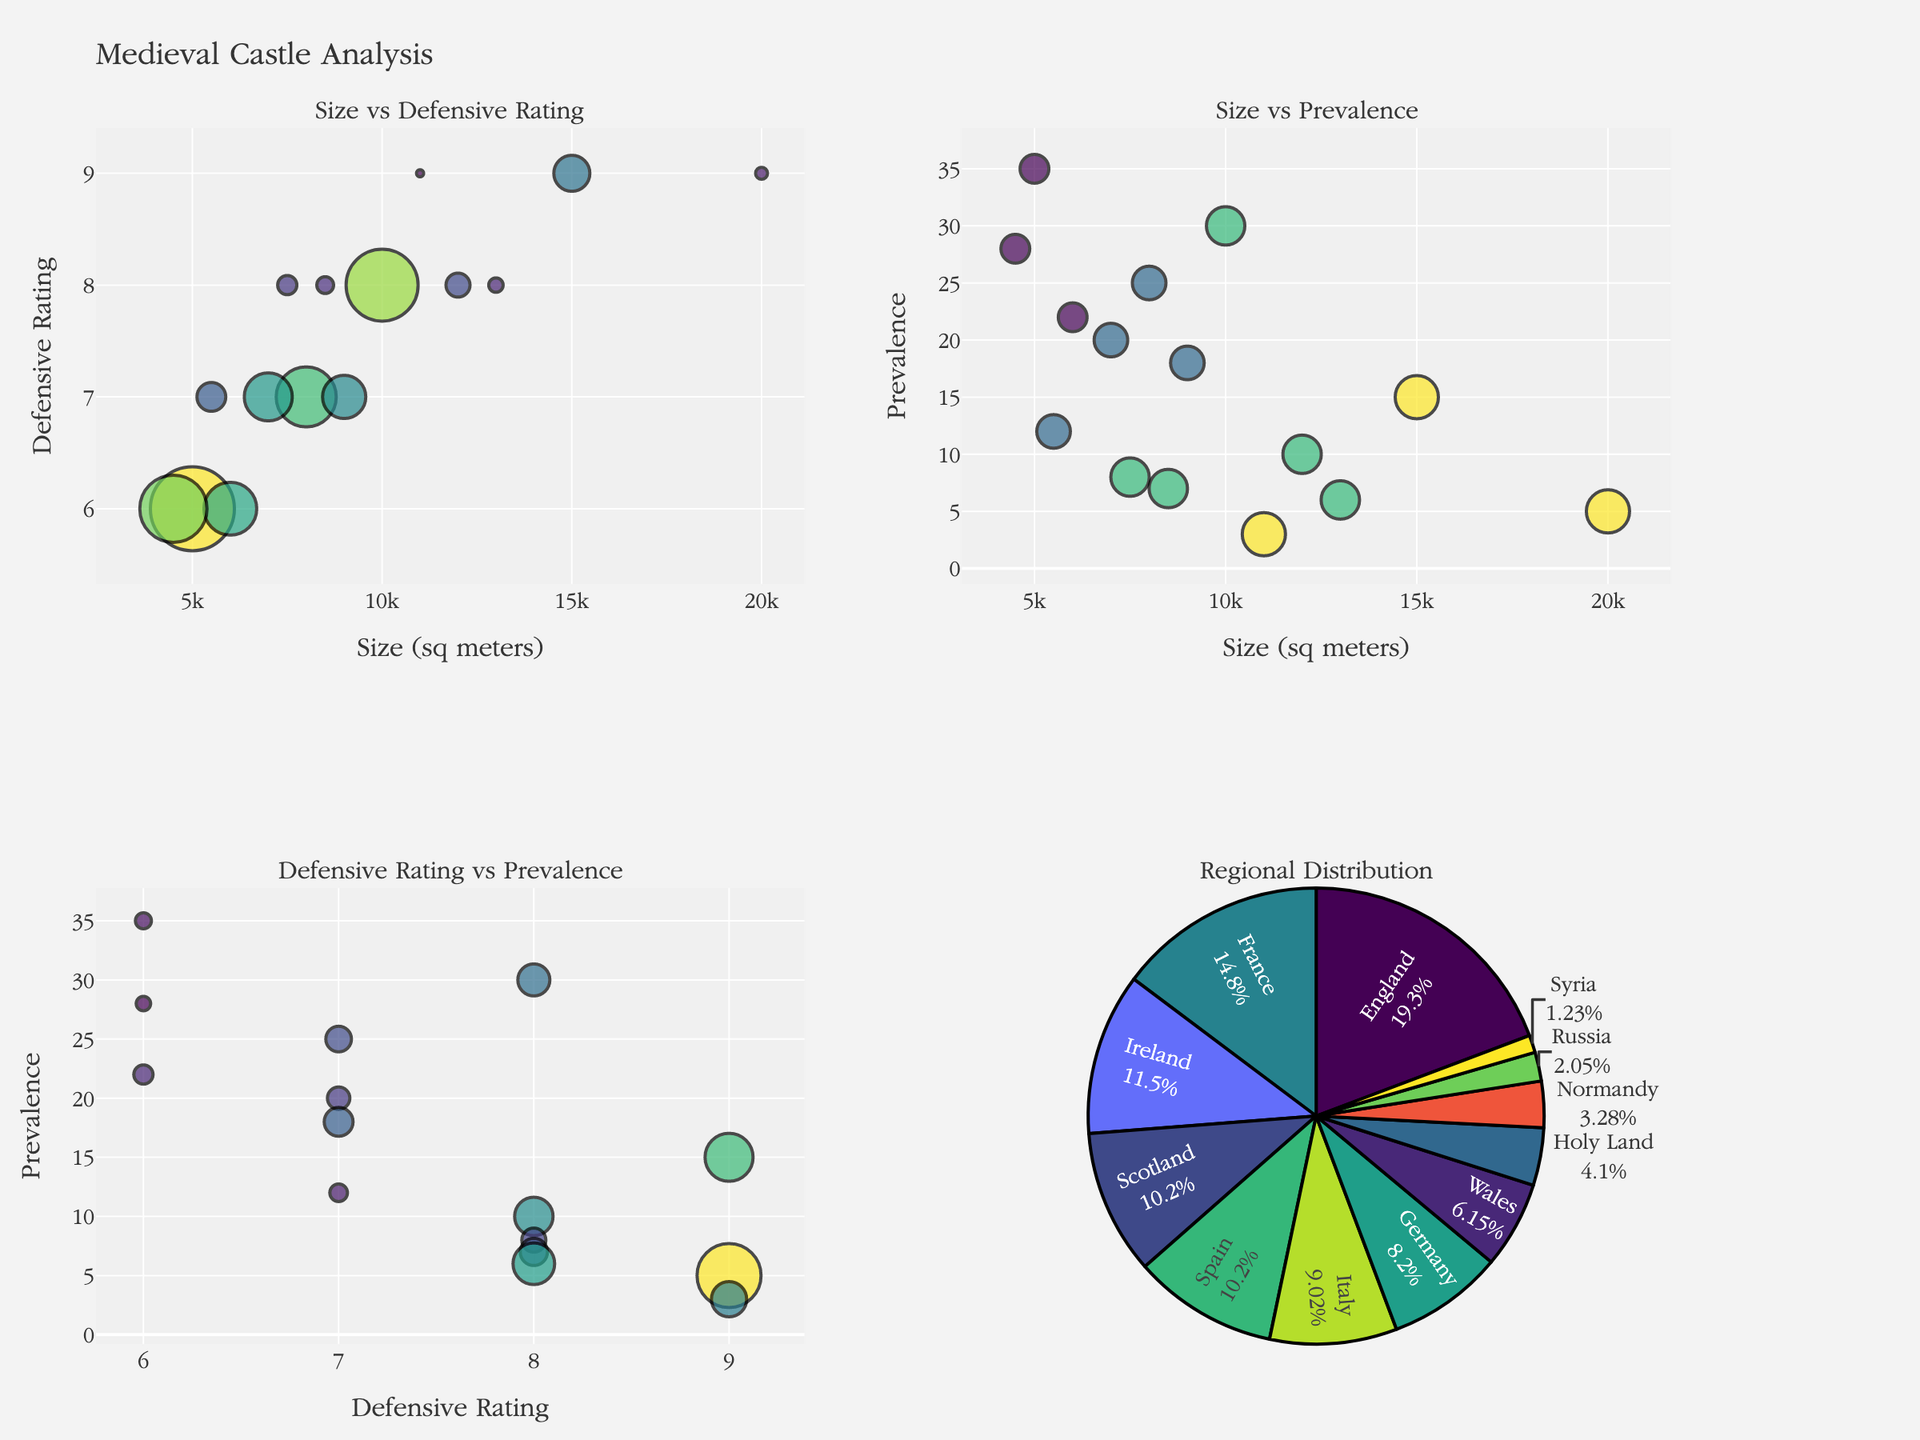what is the title of the figure? The title is usually displayed at the top of the figure. In this case, it is at the center and reads "Medieval Castle Analysis".
Answer: Medieval Castle Analysis How is the size of each bubble determined in the "Size vs Defensive Rating" subplot? The size of each bubble corresponds to the prevalence of the castle type. This can be observed by noting that the legend or visual cue indicates larger bubbles represent higher prevalence.
Answer: It is determined by prevalence Which region has the highest prevalence of castles according to the pie chart? By looking at the pie chart, we see that the region with the largest slice represents the highest prevalence. The largest slice in the pie chart is labeled "England".
Answer: England Which castle type has the highest defensive rating and what is it? In the "Size vs Defensive Rating" subplot, scan for the highest y-axis value, which is the defensive rating. The highest defensive rating is 9. The text label associated with these points indicates the castle types are "Concentric Castle", "Kremlin", and "Krak des Chevaliers".
Answer: Concentric Castle, Kremlin, Krak des Chevaliers (Defensive Rating 9) Combining the "Size vs Defensive Rating" and "Size vs Prevalence" subplots, which castle type is relatively medium-sized but highly prevalent? By cross-referencing both plots, look for a data point that appears relatively medium in size on the x-axes of both subplots and large in bubble size in the "Size vs Prevalence" subplot, representing high prevalence. The "Motte-and-Bailey" castle in "Size vs Defensive Rating" is around 5000 sq meters and the large bubble in the "Size vs Prevalence" subplot indicates it has a higher prevalence.
Answer: Motte-and-Bailey What's the average prevalence of all castles from the "Prevalence Distribution" subplot? To find the average prevalence, sum all the prevalence values and divide by the number of castle types. The sum of the prevalence values is 244 (35+15+25+10+30+20+18+5+22+3+8+12+7+6+28), divided by the number of types (15), equals approximately 16.27.
Answer: 16.27 